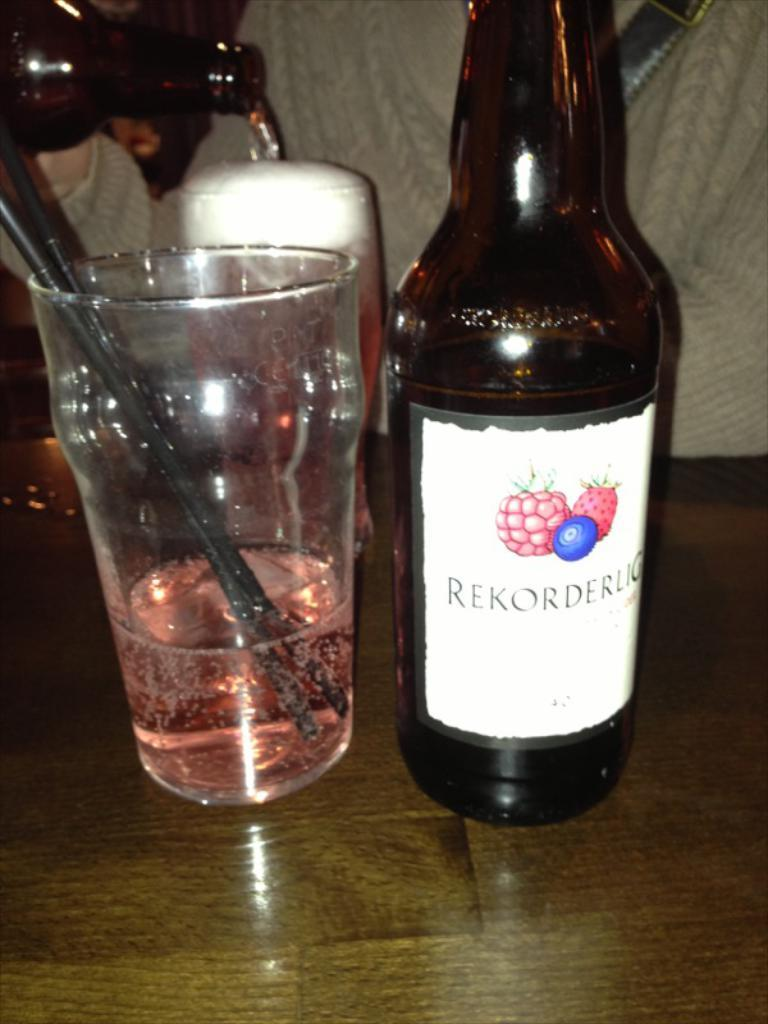Provide a one-sentence caption for the provided image. A bottle of Rekorderug has been poured into a glass. 